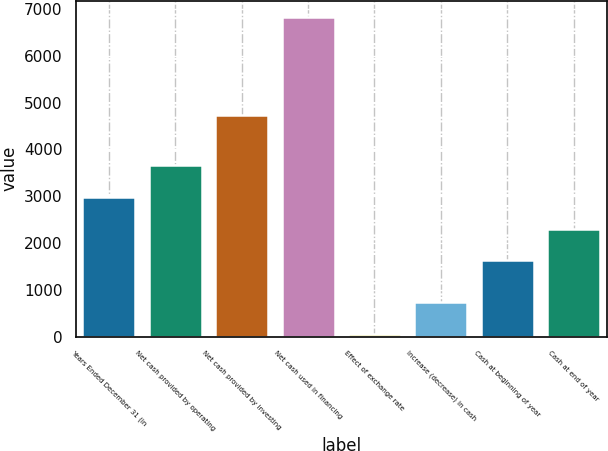Convert chart to OTSL. <chart><loc_0><loc_0><loc_500><loc_500><bar_chart><fcel>Years Ended December 31 (in<fcel>Net cash provided by operating<fcel>Net cash provided by investing<fcel>Net cash used in financing<fcel>Effect of exchange rate<fcel>Increase (decrease) in cash<fcel>Cash at beginning of year<fcel>Cash at end of year<nl><fcel>2985.2<fcel>3663.3<fcel>4744<fcel>6833<fcel>52<fcel>730.1<fcel>1629<fcel>2307.1<nl></chart> 